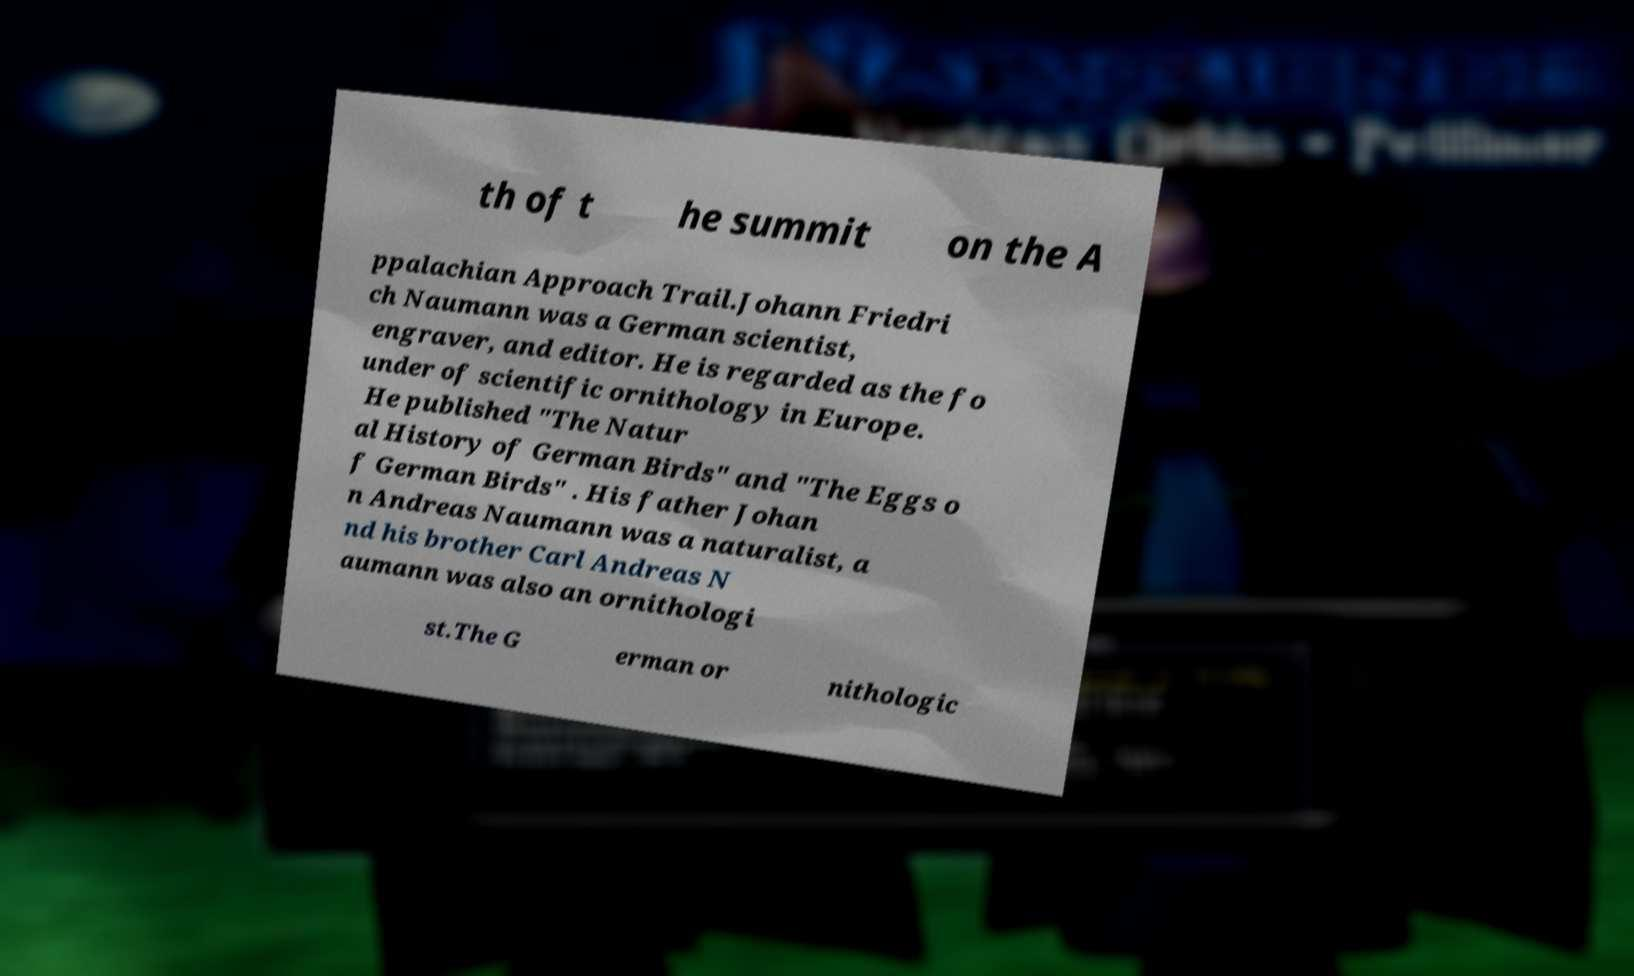What messages or text are displayed in this image? I need them in a readable, typed format. th of t he summit on the A ppalachian Approach Trail.Johann Friedri ch Naumann was a German scientist, engraver, and editor. He is regarded as the fo under of scientific ornithology in Europe. He published "The Natur al History of German Birds" and "The Eggs o f German Birds" . His father Johan n Andreas Naumann was a naturalist, a nd his brother Carl Andreas N aumann was also an ornithologi st.The G erman or nithologic 